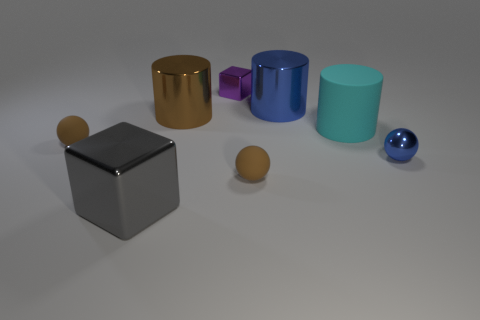What is the size of the metal object that is in front of the large brown cylinder and on the right side of the gray block?
Your response must be concise. Small. The tiny sphere that is made of the same material as the brown cylinder is what color?
Offer a very short reply. Blue. There is a rubber ball that is on the left side of the purple shiny cube; is it the same color as the small matte thing on the right side of the large brown cylinder?
Make the answer very short. Yes. The other big rubber object that is the same shape as the big brown object is what color?
Ensure brevity in your answer.  Cyan. What is the block that is in front of the matte cylinder made of?
Make the answer very short. Metal. Is there a small rubber thing that has the same color as the tiny shiny cube?
Give a very brief answer. No. There is a metal cube that is the same size as the blue ball; what is its color?
Make the answer very short. Purple. What number of tiny objects are either blue metallic objects or metal cylinders?
Make the answer very short. 1. Are there the same number of things that are left of the gray metallic cube and tiny blue shiny spheres left of the cyan thing?
Your answer should be compact. No. How many gray metallic cubes are the same size as the cyan cylinder?
Keep it short and to the point. 1. 